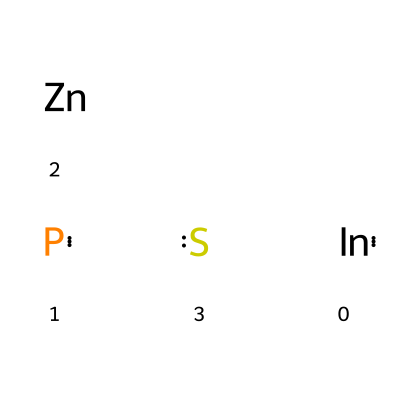What elements are present in this quantum dot? The SMILES representation shows indium (In), phosphorus (P), zinc (Zn), and sulfur (S) as distinct components of the structure.
Answer: indium, phosphorus, zinc, sulfur How many atoms are there in total? The structure includes one atom each of indium, phosphorus, zinc, and sulfur, adding up to four atoms total.
Answer: four What type of bonding is expected between the atoms in the quantum dot? The atomic structure suggests that covalent bonding will occur between these elements due to the nature of their chemical properties, especially between In and P and between Zn and S.
Answer: covalent bonding What type of quantum dot is represented by this structure? Given the specific combination of indium phosphide core and zinc sulfide shell, this quantum dot is classified as a core-shell quantum dot.
Answer: core-shell quantum dot What is the significance of the core-shell structure? The core-shell structure allows for improved optical and electronic properties, with the core providing specific electronic states and the shell enhancing stability and reducing surface defects.
Answer: improved properties How does this quantum dot affect light emission? The quantum dots exhibit size-tunable photoluminescence due to quantum confinement effects arising from the core-shell architecture, making their emission characteristics highly dependent on dimensions.
Answer: size-tunable photoluminescence 